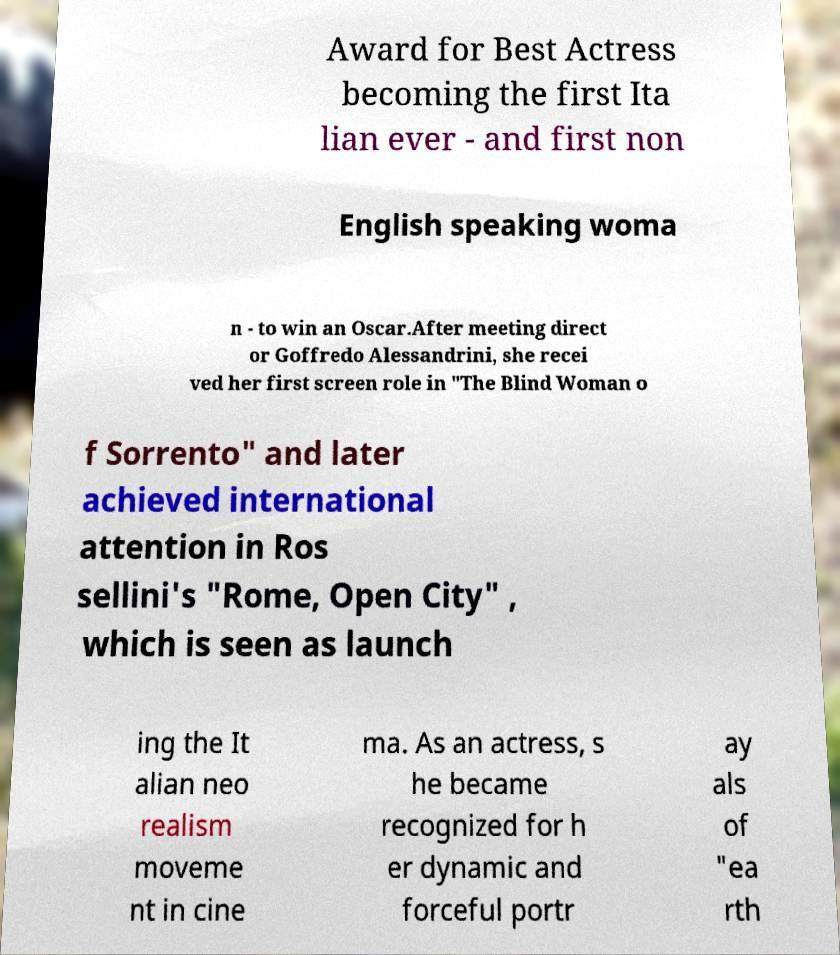Please identify and transcribe the text found in this image. Award for Best Actress becoming the first Ita lian ever - and first non English speaking woma n - to win an Oscar.After meeting direct or Goffredo Alessandrini, she recei ved her first screen role in "The Blind Woman o f Sorrento" and later achieved international attention in Ros sellini's "Rome, Open City" , which is seen as launch ing the It alian neo realism moveme nt in cine ma. As an actress, s he became recognized for h er dynamic and forceful portr ay als of "ea rth 